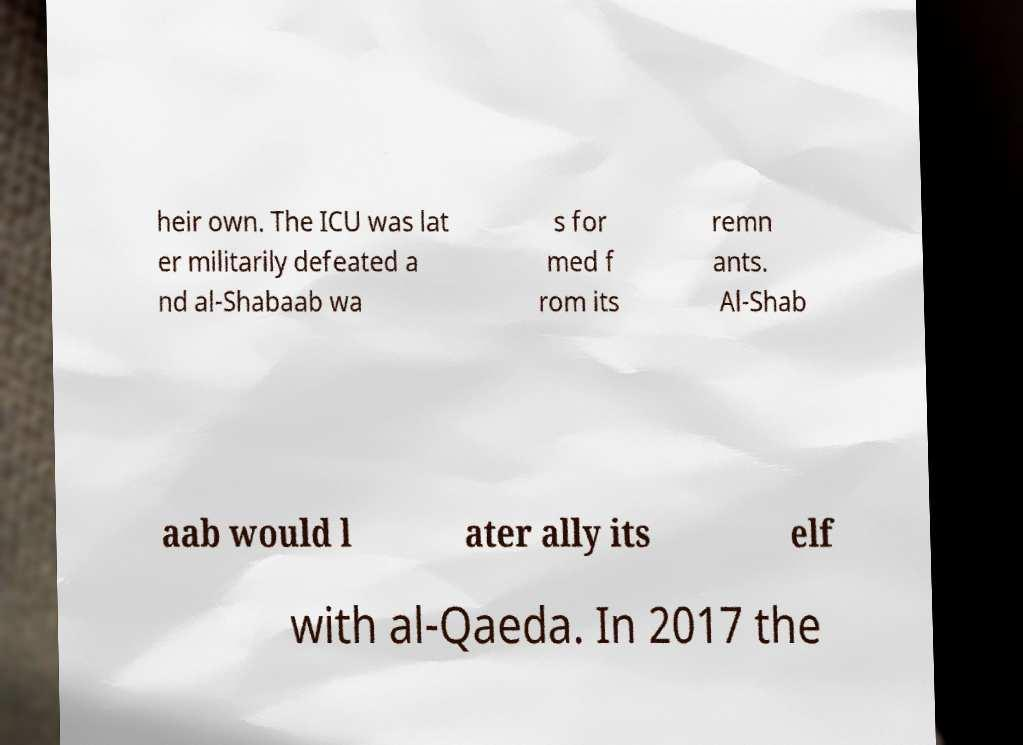Can you read and provide the text displayed in the image?This photo seems to have some interesting text. Can you extract and type it out for me? heir own. The ICU was lat er militarily defeated a nd al-Shabaab wa s for med f rom its remn ants. Al-Shab aab would l ater ally its elf with al-Qaeda. In 2017 the 